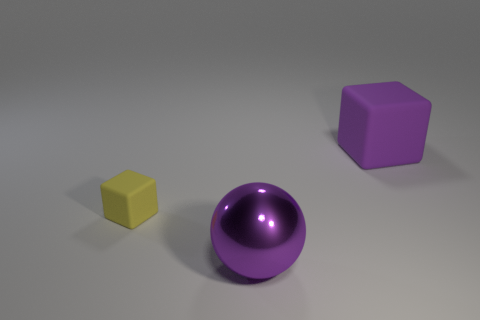Add 3 large green metal cylinders. How many objects exist? 6 Subtract all balls. How many objects are left? 2 Subtract all metal spheres. Subtract all big purple things. How many objects are left? 0 Add 3 small yellow matte objects. How many small yellow matte objects are left? 4 Add 1 large blue balls. How many large blue balls exist? 1 Subtract 0 gray cylinders. How many objects are left? 3 Subtract 1 cubes. How many cubes are left? 1 Subtract all red blocks. Subtract all purple cylinders. How many blocks are left? 2 Subtract all red spheres. How many yellow cubes are left? 1 